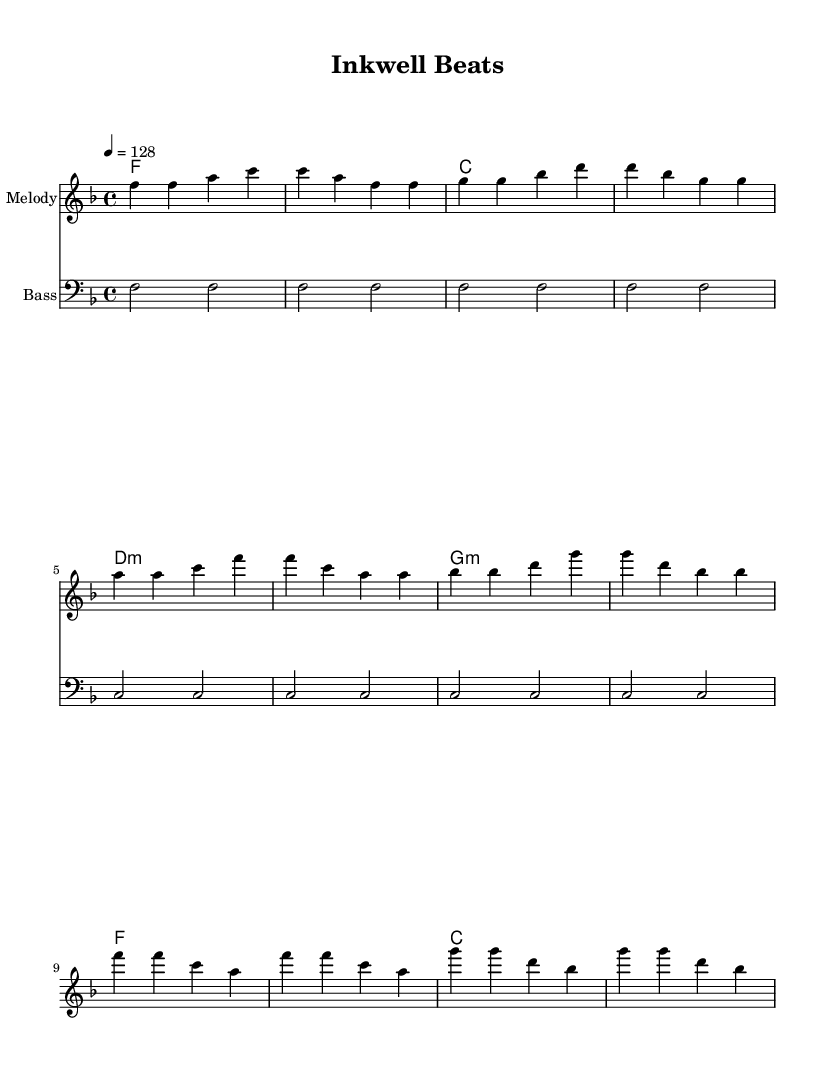What is the key signature of this music? The key signature is F major, which has one flat (B flat). This can be identified by looking at the beginning of the staff where the key signature is indicated.
Answer: F major What is the time signature of this music? The time signature is 4/4, which means there are four beats in each measure and the quarter note receives one beat. This is indicated at the beginning of the score.
Answer: 4/4 What is the tempo marking for this piece? The tempo marking is 128 beats per minute, as indicated by "4 = 128" at the beginning of the score. This tells the performer how fast to play the piece.
Answer: 128 How many measures are in the verse section? The verse section contains four measures, which can be counted by examining the melody line and counting each set of bars.
Answer: 4 What chord is used in the chorus? The chord used in the chorus is F major, which can be determined by looking at the harmony section under the chorus measures where the chord is notated.
Answer: F What is the repeating bass pattern in this piece? The repeating bass pattern consists of F and C notes, observed in the bass staff where the bass line repeats over the section.
Answer: F and C What type of music is this composed as? This music is composed as Dance, specifically upbeat electronic dance music, as indicated by the energetic tempo and structure focusing on rhythm and repetitive patterns.
Answer: Dance 